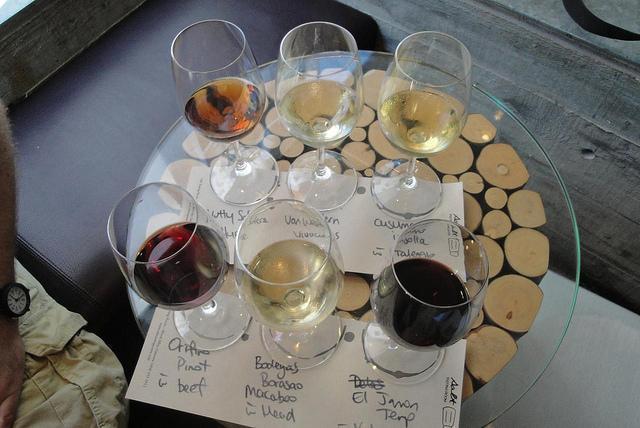How many glasses are there?
Give a very brief answer. 6. How many glasses are on the table?
Give a very brief answer. 6. How many wine glasses can you see?
Give a very brief answer. 3. 